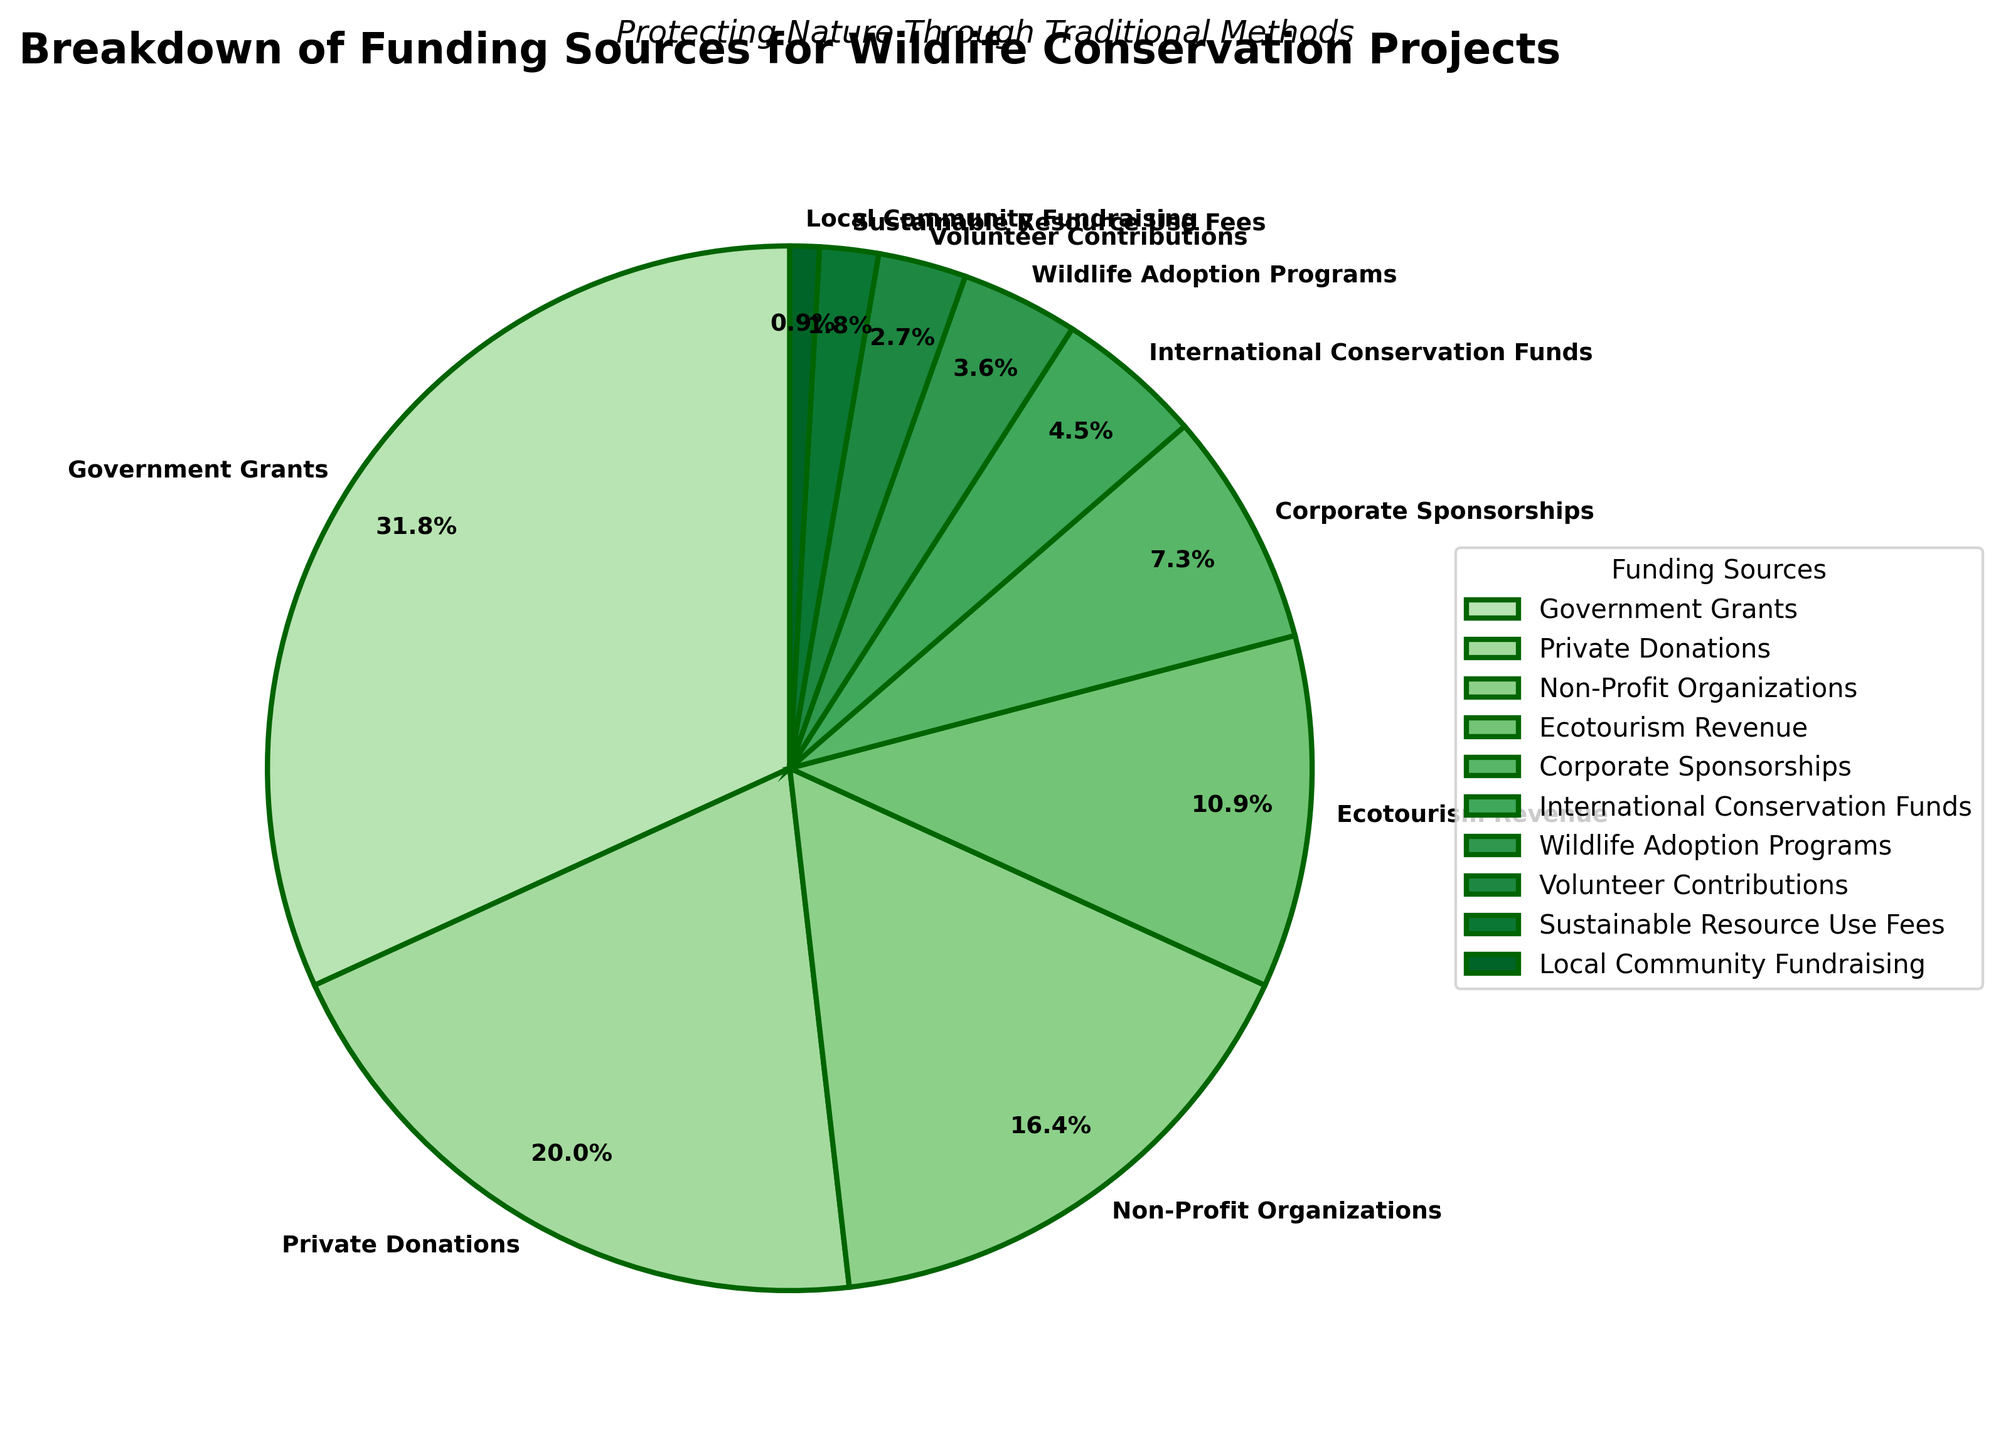What is the largest funding source for wildlife conservation projects visualized in the pie chart? The largest segment in the pie chart corresponds to Government Grants, indicated by the largest wedge size and the label showing the highest percentage.
Answer: Government Grants How many funding sources contribute together to form exactly half of the total funding? By summing the percentages, Government Grants (35%) and Private Donations (22%) alone form more than 50%. If we consider other sources, Government Grants (35%) and Private Donations (22%) together form 57%, which already exceeds 50%. However, adding Non-Profit Organizations (18%) to Private Donations would exactly make it to 50%.
Answer: Two Which two funding sources together make up more than a quarter of the total funding? By adding the percentages, the sum of Private Donations (22%) and Non-Profit Organizations (18%) is 40%, which exceeds 25%. Any other combination with a major source yields either too small or significantly exceeds 25%.
Answer: Private Donations and Non-Profit Organizations What is the approximate difference between the highest and lowest funding source percentages? The highest percentage is 35% (Government Grants), and the lowest is 1% (Local Community Fundraising). Subtracting these gives 35% - 1% = 34%.
Answer: 34% Which segment covers a larger area: Ecotourism Revenue or Corporate Sponsorships? By comparing the wedge sizes and percentages shown on the pie chart, Ecotourism Revenue is larger with 12%, whereas Corporate Sponsorships have 8%.
Answer: Ecotourism Revenue If we combine the three smallest funding sources, what fraction of the total funding do they represent? The three smallest funding sources are Local Community Fundraising (1%), Sustainable Resource Use Fees (2%), and Volunteer Contributions (3%). Summing these gives 1% + 2% + 3% = 6%.
Answer: 6% Which two funding sources have a combined percentage less than 10%? By observing the percentages, Sustainable Resource Use Fees (2%) and Local Community Fundraising (1%) together make 3%, which is less than 10%. Another pair, Wildlife Adoption Programs (4%) and Volunteer Contributions (3%), together make 7%, which is also less than 10%.
Answer: Any of the two provided pairs Are the donations from Non-Profit Organizations greater than those from Ecotourism Revenue and Corporate Sponsorships combined? Donations from Non-Profit Organizations are 18%. Combining Ecotourism Revenue (12%) and Corporate Sponsorships (8%) yields 20%, which is greater than 18%.
Answer: No 